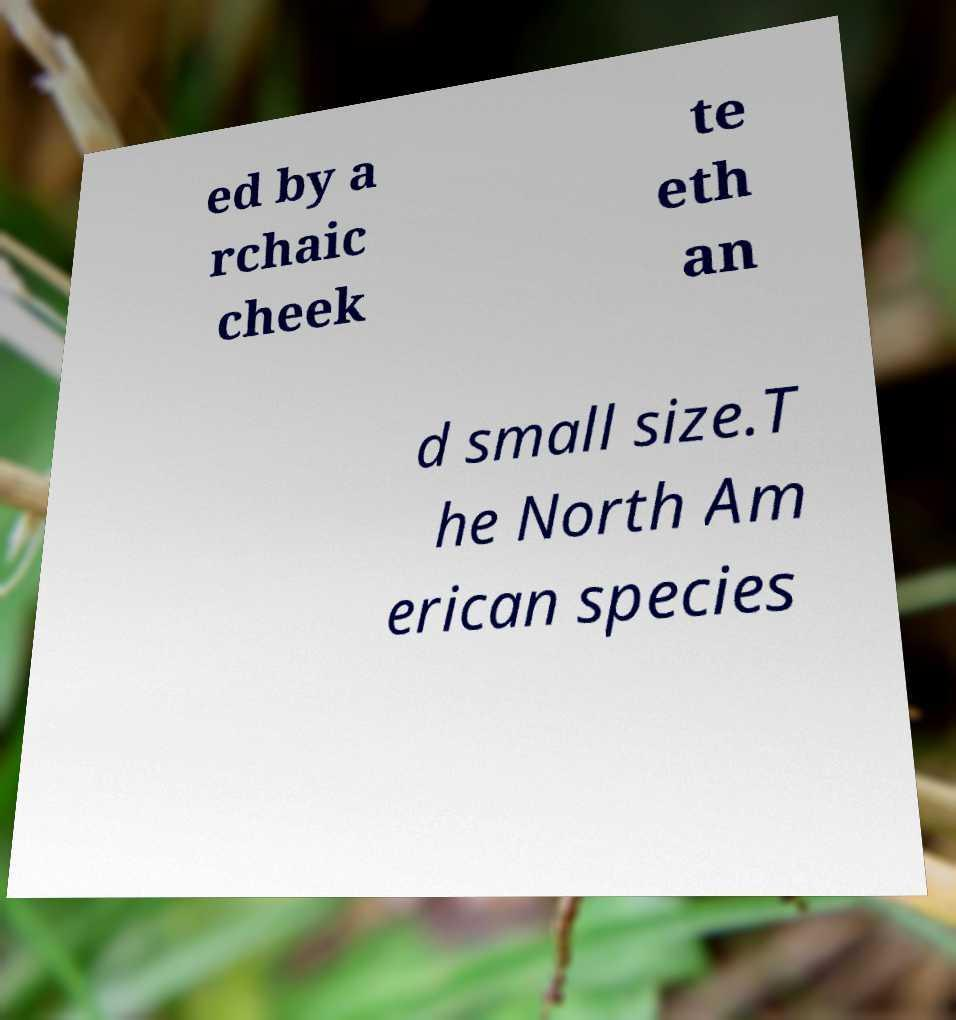Could you assist in decoding the text presented in this image and type it out clearly? ed by a rchaic cheek te eth an d small size.T he North Am erican species 